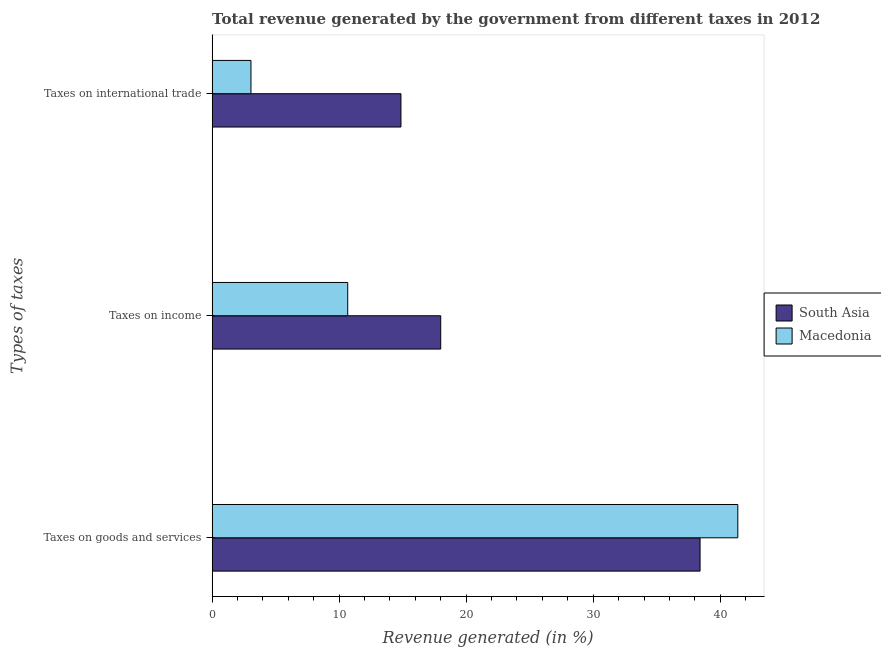How many different coloured bars are there?
Your response must be concise. 2. How many groups of bars are there?
Your answer should be compact. 3. Are the number of bars per tick equal to the number of legend labels?
Provide a short and direct response. Yes. How many bars are there on the 1st tick from the top?
Offer a very short reply. 2. How many bars are there on the 3rd tick from the bottom?
Provide a short and direct response. 2. What is the label of the 3rd group of bars from the top?
Provide a succinct answer. Taxes on goods and services. What is the percentage of revenue generated by taxes on income in Macedonia?
Your answer should be very brief. 10.67. Across all countries, what is the maximum percentage of revenue generated by taxes on income?
Your answer should be very brief. 18. Across all countries, what is the minimum percentage of revenue generated by tax on international trade?
Your answer should be compact. 3.06. In which country was the percentage of revenue generated by tax on international trade minimum?
Keep it short and to the point. Macedonia. What is the total percentage of revenue generated by tax on international trade in the graph?
Provide a short and direct response. 17.92. What is the difference between the percentage of revenue generated by taxes on goods and services in South Asia and that in Macedonia?
Keep it short and to the point. -2.97. What is the difference between the percentage of revenue generated by tax on international trade in South Asia and the percentage of revenue generated by taxes on income in Macedonia?
Make the answer very short. 4.19. What is the average percentage of revenue generated by taxes on goods and services per country?
Ensure brevity in your answer.  39.9. What is the difference between the percentage of revenue generated by taxes on goods and services and percentage of revenue generated by taxes on income in South Asia?
Provide a short and direct response. 20.42. In how many countries, is the percentage of revenue generated by tax on international trade greater than 38 %?
Your response must be concise. 0. What is the ratio of the percentage of revenue generated by tax on international trade in Macedonia to that in South Asia?
Provide a short and direct response. 0.21. Is the difference between the percentage of revenue generated by taxes on income in South Asia and Macedonia greater than the difference between the percentage of revenue generated by taxes on goods and services in South Asia and Macedonia?
Offer a very short reply. Yes. What is the difference between the highest and the second highest percentage of revenue generated by taxes on goods and services?
Your answer should be very brief. 2.97. What is the difference between the highest and the lowest percentage of revenue generated by taxes on income?
Offer a terse response. 7.32. In how many countries, is the percentage of revenue generated by taxes on income greater than the average percentage of revenue generated by taxes on income taken over all countries?
Give a very brief answer. 1. What does the 2nd bar from the bottom in Taxes on goods and services represents?
Your answer should be very brief. Macedonia. Is it the case that in every country, the sum of the percentage of revenue generated by taxes on goods and services and percentage of revenue generated by taxes on income is greater than the percentage of revenue generated by tax on international trade?
Keep it short and to the point. Yes. How many bars are there?
Give a very brief answer. 6. How many countries are there in the graph?
Offer a very short reply. 2. What is the difference between two consecutive major ticks on the X-axis?
Provide a short and direct response. 10. Does the graph contain any zero values?
Ensure brevity in your answer.  No. Does the graph contain grids?
Your answer should be compact. No. What is the title of the graph?
Your answer should be compact. Total revenue generated by the government from different taxes in 2012. Does "Low & middle income" appear as one of the legend labels in the graph?
Provide a succinct answer. No. What is the label or title of the X-axis?
Offer a very short reply. Revenue generated (in %). What is the label or title of the Y-axis?
Keep it short and to the point. Types of taxes. What is the Revenue generated (in %) in South Asia in Taxes on goods and services?
Your answer should be very brief. 38.41. What is the Revenue generated (in %) in Macedonia in Taxes on goods and services?
Offer a terse response. 41.39. What is the Revenue generated (in %) in South Asia in Taxes on income?
Provide a short and direct response. 18. What is the Revenue generated (in %) of Macedonia in Taxes on income?
Your answer should be very brief. 10.67. What is the Revenue generated (in %) of South Asia in Taxes on international trade?
Your answer should be very brief. 14.87. What is the Revenue generated (in %) in Macedonia in Taxes on international trade?
Your answer should be very brief. 3.06. Across all Types of taxes, what is the maximum Revenue generated (in %) in South Asia?
Provide a succinct answer. 38.41. Across all Types of taxes, what is the maximum Revenue generated (in %) in Macedonia?
Provide a short and direct response. 41.39. Across all Types of taxes, what is the minimum Revenue generated (in %) in South Asia?
Offer a very short reply. 14.87. Across all Types of taxes, what is the minimum Revenue generated (in %) of Macedonia?
Give a very brief answer. 3.06. What is the total Revenue generated (in %) of South Asia in the graph?
Ensure brevity in your answer.  71.28. What is the total Revenue generated (in %) in Macedonia in the graph?
Provide a succinct answer. 55.12. What is the difference between the Revenue generated (in %) of South Asia in Taxes on goods and services and that in Taxes on income?
Your answer should be compact. 20.42. What is the difference between the Revenue generated (in %) in Macedonia in Taxes on goods and services and that in Taxes on income?
Ensure brevity in your answer.  30.71. What is the difference between the Revenue generated (in %) in South Asia in Taxes on goods and services and that in Taxes on international trade?
Provide a short and direct response. 23.55. What is the difference between the Revenue generated (in %) in Macedonia in Taxes on goods and services and that in Taxes on international trade?
Provide a succinct answer. 38.33. What is the difference between the Revenue generated (in %) in South Asia in Taxes on income and that in Taxes on international trade?
Offer a terse response. 3.13. What is the difference between the Revenue generated (in %) in Macedonia in Taxes on income and that in Taxes on international trade?
Provide a succinct answer. 7.62. What is the difference between the Revenue generated (in %) in South Asia in Taxes on goods and services and the Revenue generated (in %) in Macedonia in Taxes on income?
Provide a succinct answer. 27.74. What is the difference between the Revenue generated (in %) of South Asia in Taxes on goods and services and the Revenue generated (in %) of Macedonia in Taxes on international trade?
Ensure brevity in your answer.  35.36. What is the difference between the Revenue generated (in %) in South Asia in Taxes on income and the Revenue generated (in %) in Macedonia in Taxes on international trade?
Provide a short and direct response. 14.94. What is the average Revenue generated (in %) in South Asia per Types of taxes?
Make the answer very short. 23.76. What is the average Revenue generated (in %) in Macedonia per Types of taxes?
Offer a very short reply. 18.37. What is the difference between the Revenue generated (in %) in South Asia and Revenue generated (in %) in Macedonia in Taxes on goods and services?
Ensure brevity in your answer.  -2.97. What is the difference between the Revenue generated (in %) of South Asia and Revenue generated (in %) of Macedonia in Taxes on income?
Your answer should be compact. 7.32. What is the difference between the Revenue generated (in %) in South Asia and Revenue generated (in %) in Macedonia in Taxes on international trade?
Your answer should be very brief. 11.81. What is the ratio of the Revenue generated (in %) in South Asia in Taxes on goods and services to that in Taxes on income?
Provide a short and direct response. 2.13. What is the ratio of the Revenue generated (in %) in Macedonia in Taxes on goods and services to that in Taxes on income?
Provide a succinct answer. 3.88. What is the ratio of the Revenue generated (in %) of South Asia in Taxes on goods and services to that in Taxes on international trade?
Ensure brevity in your answer.  2.58. What is the ratio of the Revenue generated (in %) of Macedonia in Taxes on goods and services to that in Taxes on international trade?
Your answer should be compact. 13.54. What is the ratio of the Revenue generated (in %) in South Asia in Taxes on income to that in Taxes on international trade?
Offer a very short reply. 1.21. What is the ratio of the Revenue generated (in %) in Macedonia in Taxes on income to that in Taxes on international trade?
Your answer should be very brief. 3.49. What is the difference between the highest and the second highest Revenue generated (in %) in South Asia?
Ensure brevity in your answer.  20.42. What is the difference between the highest and the second highest Revenue generated (in %) in Macedonia?
Offer a terse response. 30.71. What is the difference between the highest and the lowest Revenue generated (in %) of South Asia?
Your answer should be compact. 23.55. What is the difference between the highest and the lowest Revenue generated (in %) of Macedonia?
Offer a terse response. 38.33. 